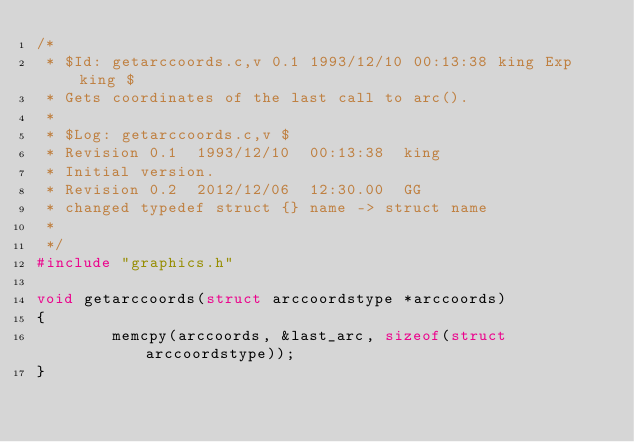<code> <loc_0><loc_0><loc_500><loc_500><_C_>/* 
 * $Id: getarccoords.c,v 0.1 1993/12/10 00:13:38 king Exp king $
 * Gets coordinates of the last call to arc().
 *
 * $Log: getarccoords.c,v $
 * Revision 0.1  1993/12/10  00:13:38  king
 * Initial version.
 * Revision 0.2  2012/12/06  12:30.00  GG
 * changed typedef struct {} name -> struct name
 *
 */
#include "graphics.h"

void getarccoords(struct arccoordstype *arccoords)
{
        memcpy(arccoords, &last_arc, sizeof(struct arccoordstype));
}
</code> 